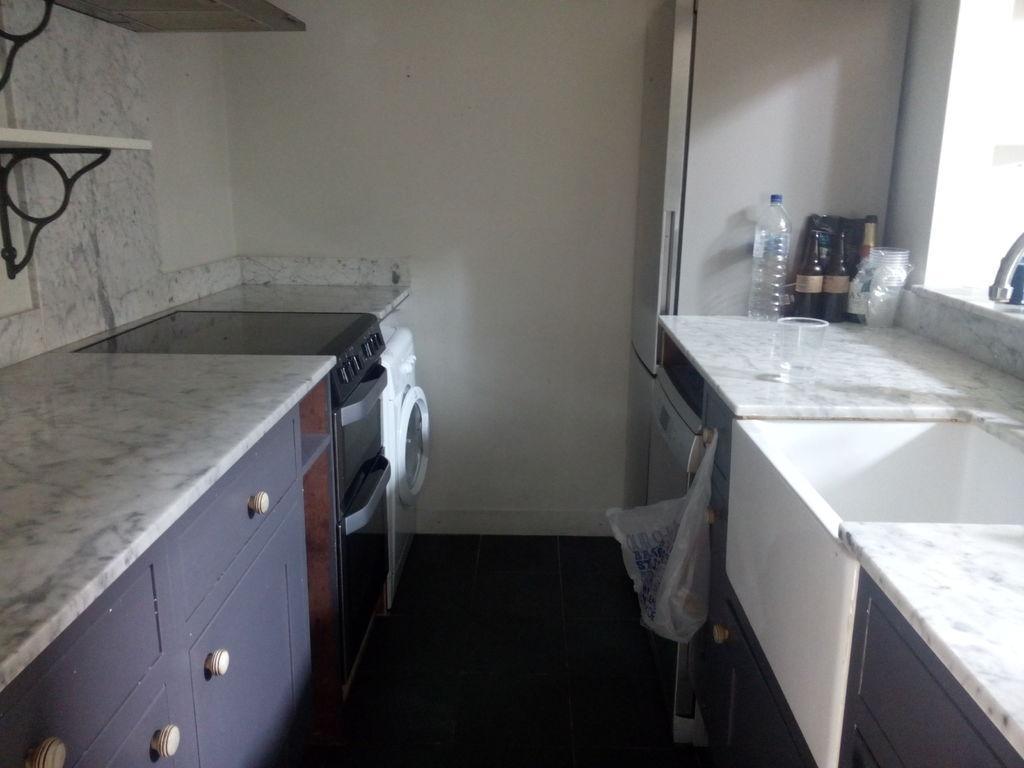Could you give a brief overview of what you see in this image? In this picture there is a washing machine, oven and shelf also there is a wash basin, empty disposable glasses, Bottles And water bottle is also refrigerator and there is plastic cover hang over here 